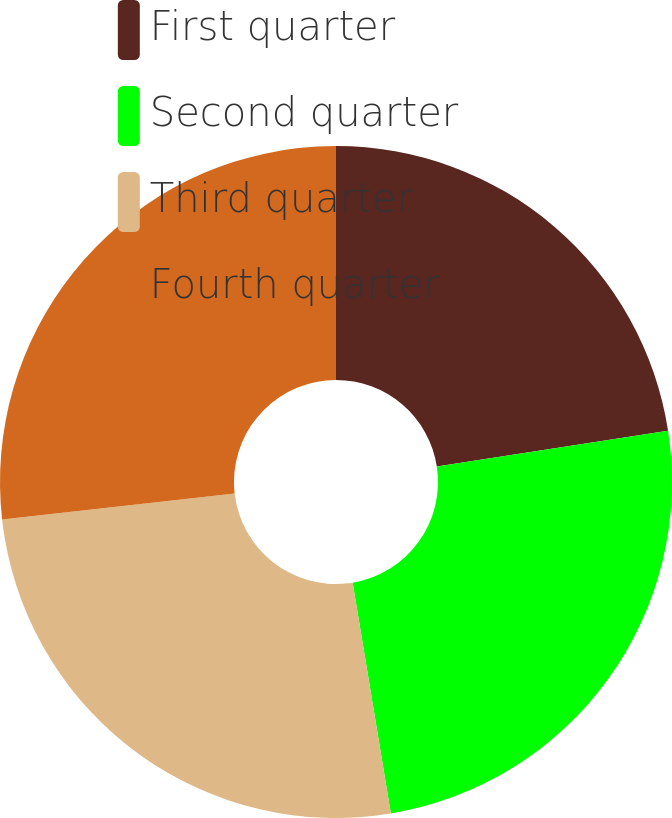Convert chart to OTSL. <chart><loc_0><loc_0><loc_500><loc_500><pie_chart><fcel>First quarter<fcel>Second quarter<fcel>Third quarter<fcel>Fourth quarter<nl><fcel>22.56%<fcel>24.83%<fcel>25.83%<fcel>26.78%<nl></chart> 